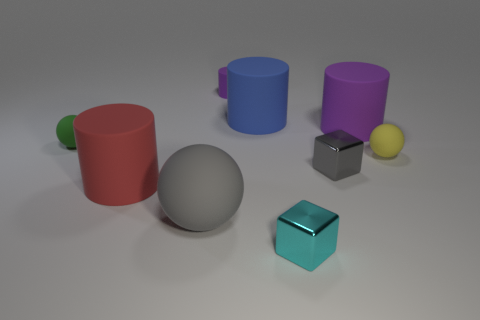Add 1 tiny cyan objects. How many objects exist? 10 Subtract all yellow balls. How many balls are left? 2 Subtract all tiny green matte balls. How many balls are left? 2 Subtract all blocks. How many objects are left? 7 Subtract 1 spheres. How many spheres are left? 2 Add 1 large rubber objects. How many large rubber objects exist? 5 Subtract 0 brown cylinders. How many objects are left? 9 Subtract all blue cylinders. Subtract all red spheres. How many cylinders are left? 3 Subtract all brown cubes. How many yellow cylinders are left? 0 Subtract all matte objects. Subtract all small yellow rubber objects. How many objects are left? 1 